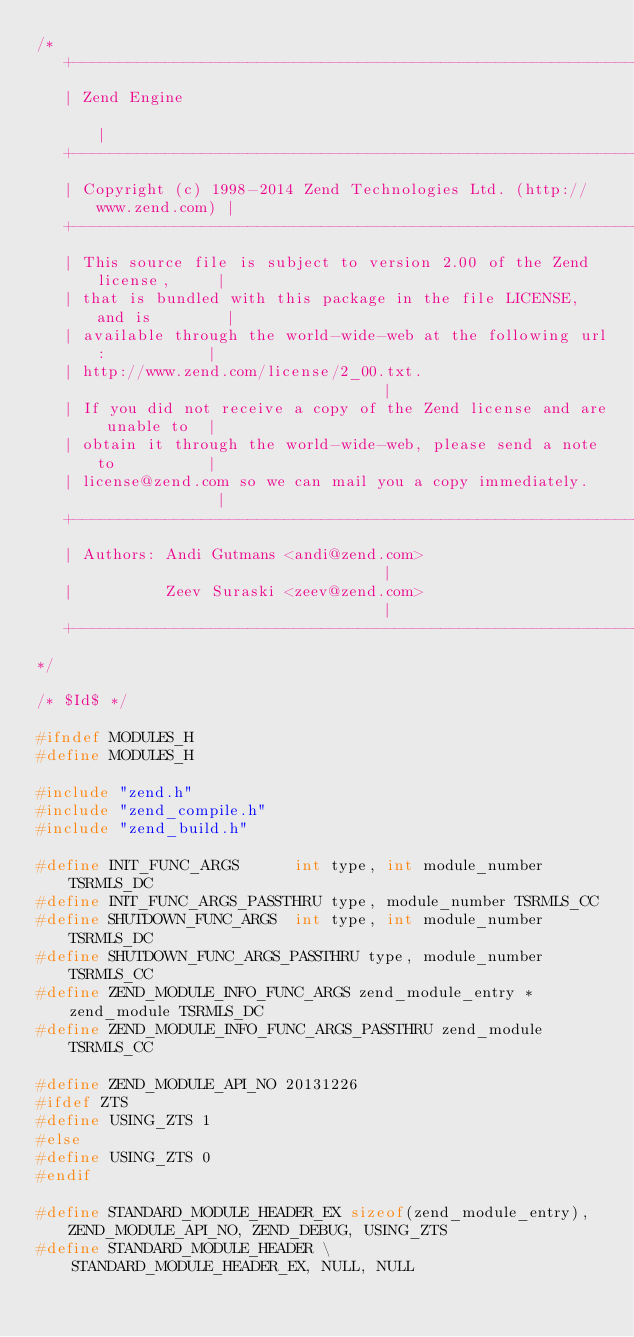<code> <loc_0><loc_0><loc_500><loc_500><_C_>/*
   +----------------------------------------------------------------------+
   | Zend Engine                                                          |
   +----------------------------------------------------------------------+
   | Copyright (c) 1998-2014 Zend Technologies Ltd. (http://www.zend.com) |
   +----------------------------------------------------------------------+
   | This source file is subject to version 2.00 of the Zend license,     |
   | that is bundled with this package in the file LICENSE, and is        |
   | available through the world-wide-web at the following url:           |
   | http://www.zend.com/license/2_00.txt.                                |
   | If you did not receive a copy of the Zend license and are unable to  |
   | obtain it through the world-wide-web, please send a note to          |
   | license@zend.com so we can mail you a copy immediately.              |
   +----------------------------------------------------------------------+
   | Authors: Andi Gutmans <andi@zend.com>                                |
   |          Zeev Suraski <zeev@zend.com>                                |
   +----------------------------------------------------------------------+
*/

/* $Id$ */

#ifndef MODULES_H
#define MODULES_H

#include "zend.h"
#include "zend_compile.h"
#include "zend_build.h"

#define INIT_FUNC_ARGS		int type, int module_number TSRMLS_DC
#define INIT_FUNC_ARGS_PASSTHRU	type, module_number TSRMLS_CC
#define SHUTDOWN_FUNC_ARGS	int type, int module_number TSRMLS_DC
#define SHUTDOWN_FUNC_ARGS_PASSTHRU type, module_number TSRMLS_CC
#define ZEND_MODULE_INFO_FUNC_ARGS zend_module_entry *zend_module TSRMLS_DC
#define ZEND_MODULE_INFO_FUNC_ARGS_PASSTHRU zend_module TSRMLS_CC

#define ZEND_MODULE_API_NO 20131226
#ifdef ZTS
#define USING_ZTS 1
#else
#define USING_ZTS 0
#endif

#define STANDARD_MODULE_HEADER_EX sizeof(zend_module_entry), ZEND_MODULE_API_NO, ZEND_DEBUG, USING_ZTS
#define STANDARD_MODULE_HEADER \
	STANDARD_MODULE_HEADER_EX, NULL, NULL</code> 